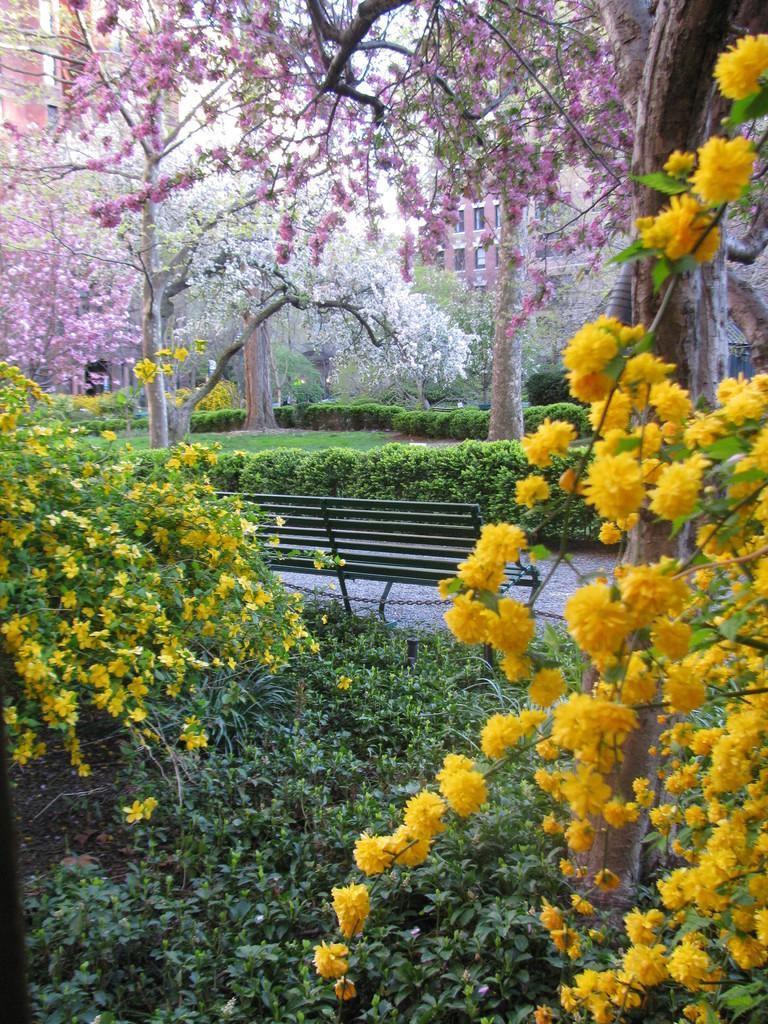What type of vegetation can be seen in the background of the image? There are trees in the background of the image. What type of vegetation can be seen in the foreground of the image? There are flowers in the foreground of the image. What other type of vegetation is present in the image? There are plants in the image. What type of seating is visible in the image? There is a bench in the center of the image. What type of patch is visible on the bench in the image? There is no patch visible on the bench in the image. What type of bomb can be seen in the image? There is no bomb present in the image. 